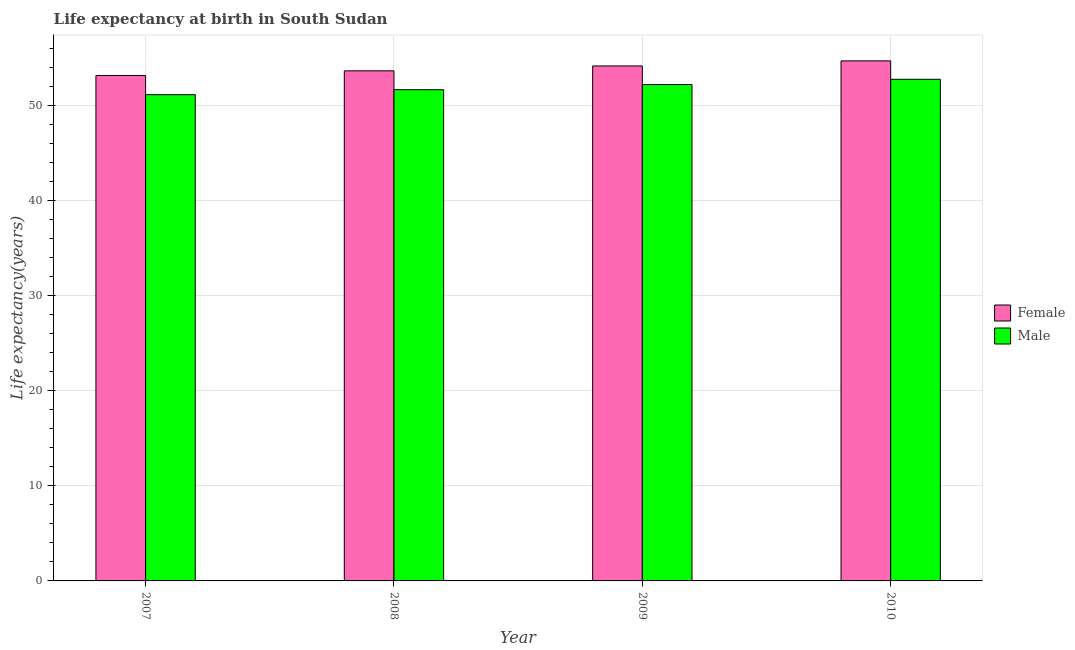How many different coloured bars are there?
Keep it short and to the point. 2. Are the number of bars per tick equal to the number of legend labels?
Provide a short and direct response. Yes. Are the number of bars on each tick of the X-axis equal?
Your answer should be compact. Yes. What is the life expectancy(male) in 2010?
Ensure brevity in your answer.  52.72. Across all years, what is the maximum life expectancy(male)?
Offer a very short reply. 52.72. Across all years, what is the minimum life expectancy(female)?
Offer a terse response. 53.12. In which year was the life expectancy(female) maximum?
Ensure brevity in your answer.  2010. What is the total life expectancy(female) in the graph?
Provide a succinct answer. 215.51. What is the difference between the life expectancy(male) in 2009 and that in 2010?
Make the answer very short. -0.55. What is the difference between the life expectancy(male) in 2008 and the life expectancy(female) in 2009?
Give a very brief answer. -0.54. What is the average life expectancy(female) per year?
Your answer should be very brief. 53.88. What is the ratio of the life expectancy(female) in 2008 to that in 2009?
Provide a short and direct response. 0.99. Is the life expectancy(male) in 2007 less than that in 2010?
Offer a very short reply. Yes. What is the difference between the highest and the second highest life expectancy(female)?
Your answer should be very brief. 0.53. What is the difference between the highest and the lowest life expectancy(female)?
Offer a very short reply. 1.53. Is the sum of the life expectancy(male) in 2007 and 2008 greater than the maximum life expectancy(female) across all years?
Offer a terse response. Yes. What does the 1st bar from the right in 2010 represents?
Your answer should be compact. Male. How many bars are there?
Ensure brevity in your answer.  8. Are all the bars in the graph horizontal?
Offer a terse response. No. How many years are there in the graph?
Your answer should be compact. 4. Does the graph contain any zero values?
Provide a succinct answer. No. What is the title of the graph?
Your response must be concise. Life expectancy at birth in South Sudan. Does "Canada" appear as one of the legend labels in the graph?
Provide a succinct answer. No. What is the label or title of the Y-axis?
Your response must be concise. Life expectancy(years). What is the Life expectancy(years) of Female in 2007?
Provide a succinct answer. 53.12. What is the Life expectancy(years) in Male in 2007?
Offer a very short reply. 51.1. What is the Life expectancy(years) in Female in 2008?
Give a very brief answer. 53.61. What is the Life expectancy(years) in Male in 2008?
Ensure brevity in your answer.  51.63. What is the Life expectancy(years) in Female in 2009?
Your response must be concise. 54.12. What is the Life expectancy(years) of Male in 2009?
Make the answer very short. 52.17. What is the Life expectancy(years) of Female in 2010?
Give a very brief answer. 54.66. What is the Life expectancy(years) in Male in 2010?
Your answer should be very brief. 52.72. Across all years, what is the maximum Life expectancy(years) in Female?
Give a very brief answer. 54.66. Across all years, what is the maximum Life expectancy(years) in Male?
Your answer should be compact. 52.72. Across all years, what is the minimum Life expectancy(years) of Female?
Your answer should be very brief. 53.12. Across all years, what is the minimum Life expectancy(years) in Male?
Provide a short and direct response. 51.1. What is the total Life expectancy(years) in Female in the graph?
Keep it short and to the point. 215.51. What is the total Life expectancy(years) in Male in the graph?
Ensure brevity in your answer.  207.62. What is the difference between the Life expectancy(years) of Female in 2007 and that in 2008?
Ensure brevity in your answer.  -0.49. What is the difference between the Life expectancy(years) in Male in 2007 and that in 2008?
Your answer should be very brief. -0.52. What is the difference between the Life expectancy(years) in Female in 2007 and that in 2009?
Give a very brief answer. -1. What is the difference between the Life expectancy(years) of Male in 2007 and that in 2009?
Give a very brief answer. -1.07. What is the difference between the Life expectancy(years) of Female in 2007 and that in 2010?
Ensure brevity in your answer.  -1.53. What is the difference between the Life expectancy(years) of Male in 2007 and that in 2010?
Offer a terse response. -1.62. What is the difference between the Life expectancy(years) in Female in 2008 and that in 2009?
Make the answer very short. -0.52. What is the difference between the Life expectancy(years) of Male in 2008 and that in 2009?
Keep it short and to the point. -0.54. What is the difference between the Life expectancy(years) in Female in 2008 and that in 2010?
Provide a short and direct response. -1.05. What is the difference between the Life expectancy(years) in Male in 2008 and that in 2010?
Your answer should be compact. -1.09. What is the difference between the Life expectancy(years) in Female in 2009 and that in 2010?
Your response must be concise. -0.53. What is the difference between the Life expectancy(years) of Male in 2009 and that in 2010?
Give a very brief answer. -0.55. What is the difference between the Life expectancy(years) of Female in 2007 and the Life expectancy(years) of Male in 2008?
Provide a succinct answer. 1.5. What is the difference between the Life expectancy(years) in Female in 2007 and the Life expectancy(years) in Male in 2009?
Offer a very short reply. 0.95. What is the difference between the Life expectancy(years) of Female in 2007 and the Life expectancy(years) of Male in 2010?
Give a very brief answer. 0.4. What is the difference between the Life expectancy(years) of Female in 2008 and the Life expectancy(years) of Male in 2009?
Your response must be concise. 1.44. What is the difference between the Life expectancy(years) of Female in 2008 and the Life expectancy(years) of Male in 2010?
Make the answer very short. 0.89. What is the difference between the Life expectancy(years) in Female in 2009 and the Life expectancy(years) in Male in 2010?
Ensure brevity in your answer.  1.4. What is the average Life expectancy(years) in Female per year?
Keep it short and to the point. 53.88. What is the average Life expectancy(years) in Male per year?
Give a very brief answer. 51.9. In the year 2007, what is the difference between the Life expectancy(years) of Female and Life expectancy(years) of Male?
Provide a succinct answer. 2.02. In the year 2008, what is the difference between the Life expectancy(years) in Female and Life expectancy(years) in Male?
Provide a succinct answer. 1.98. In the year 2009, what is the difference between the Life expectancy(years) in Female and Life expectancy(years) in Male?
Offer a terse response. 1.96. In the year 2010, what is the difference between the Life expectancy(years) in Female and Life expectancy(years) in Male?
Give a very brief answer. 1.94. What is the ratio of the Life expectancy(years) in Female in 2007 to that in 2008?
Your answer should be compact. 0.99. What is the ratio of the Life expectancy(years) in Female in 2007 to that in 2009?
Provide a short and direct response. 0.98. What is the ratio of the Life expectancy(years) of Male in 2007 to that in 2009?
Your answer should be compact. 0.98. What is the ratio of the Life expectancy(years) in Female in 2007 to that in 2010?
Offer a terse response. 0.97. What is the ratio of the Life expectancy(years) of Male in 2007 to that in 2010?
Provide a succinct answer. 0.97. What is the ratio of the Life expectancy(years) of Female in 2008 to that in 2010?
Offer a very short reply. 0.98. What is the ratio of the Life expectancy(years) of Male in 2008 to that in 2010?
Give a very brief answer. 0.98. What is the ratio of the Life expectancy(years) in Female in 2009 to that in 2010?
Provide a succinct answer. 0.99. What is the ratio of the Life expectancy(years) in Male in 2009 to that in 2010?
Provide a succinct answer. 0.99. What is the difference between the highest and the second highest Life expectancy(years) in Female?
Your response must be concise. 0.53. What is the difference between the highest and the second highest Life expectancy(years) of Male?
Offer a terse response. 0.55. What is the difference between the highest and the lowest Life expectancy(years) in Female?
Ensure brevity in your answer.  1.53. What is the difference between the highest and the lowest Life expectancy(years) of Male?
Your answer should be very brief. 1.62. 